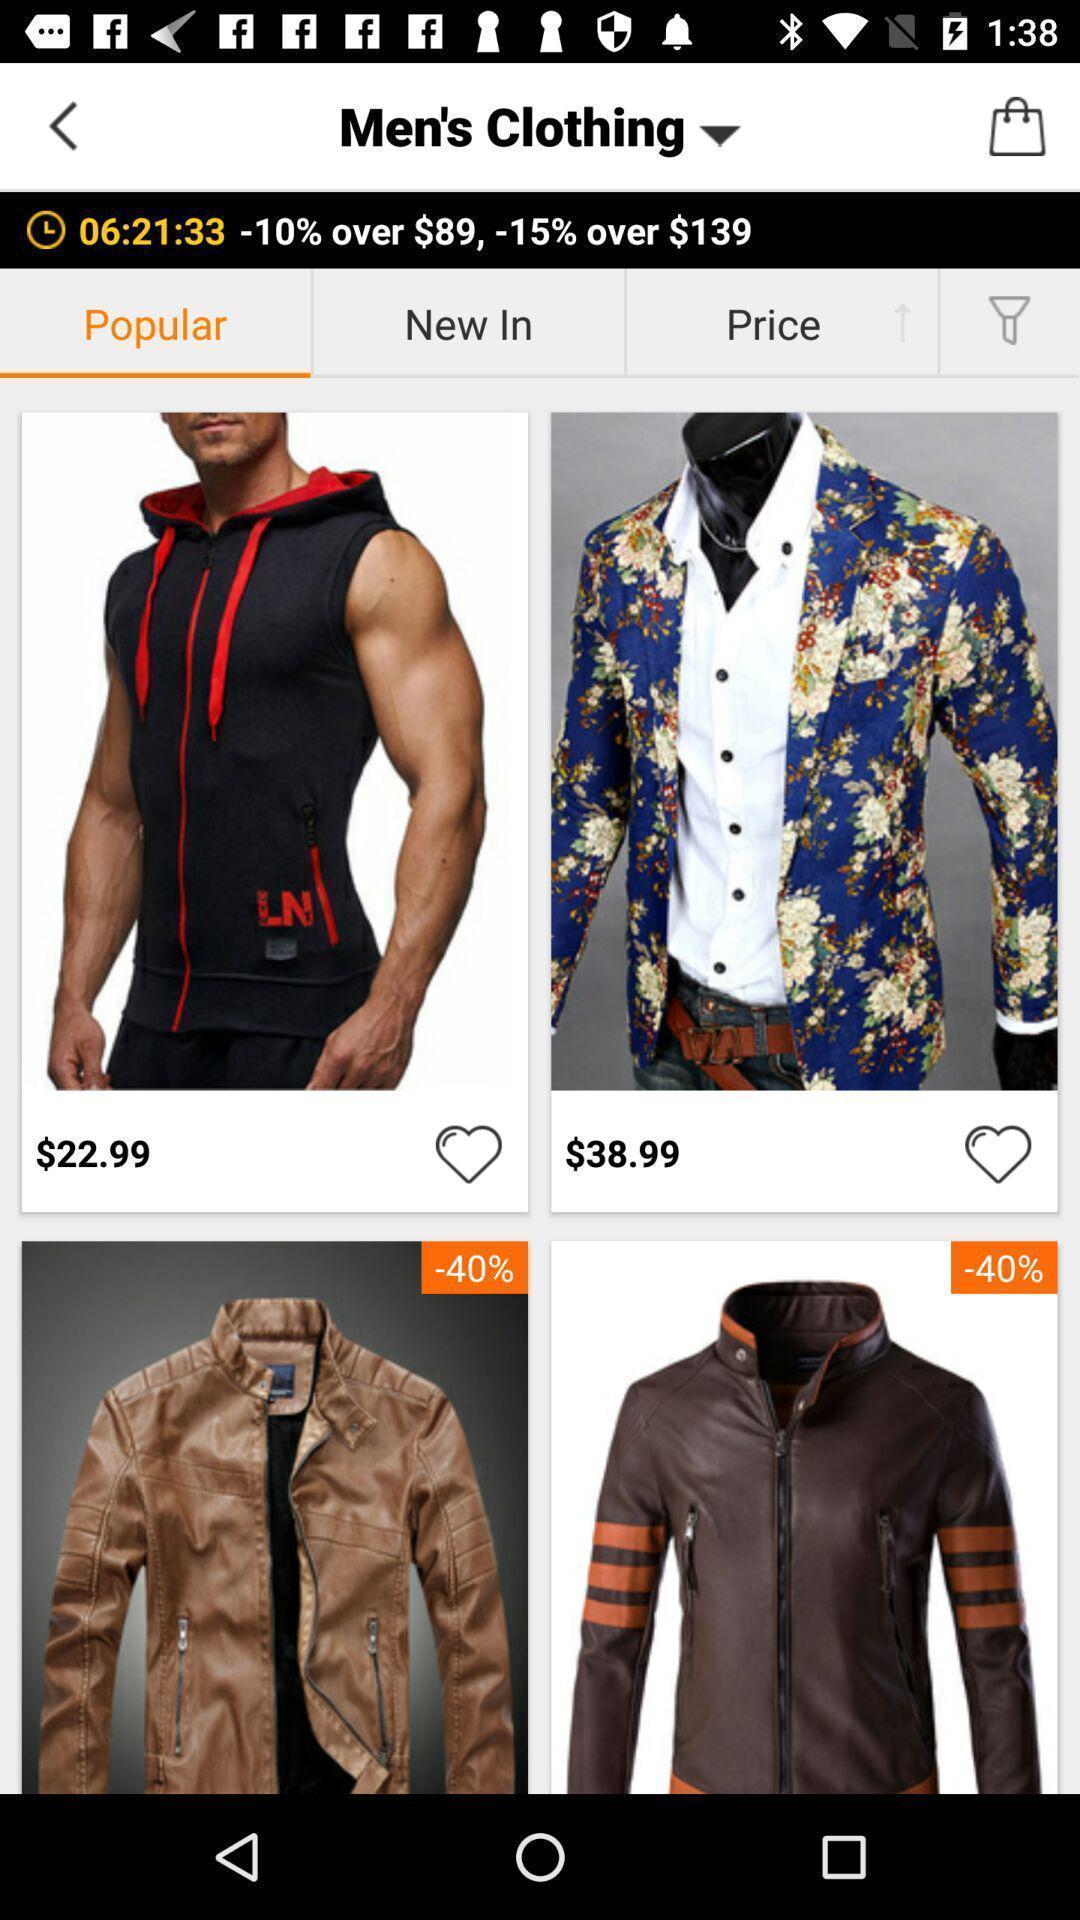Summarize the information in this screenshot. Window displaying online shopping app. 